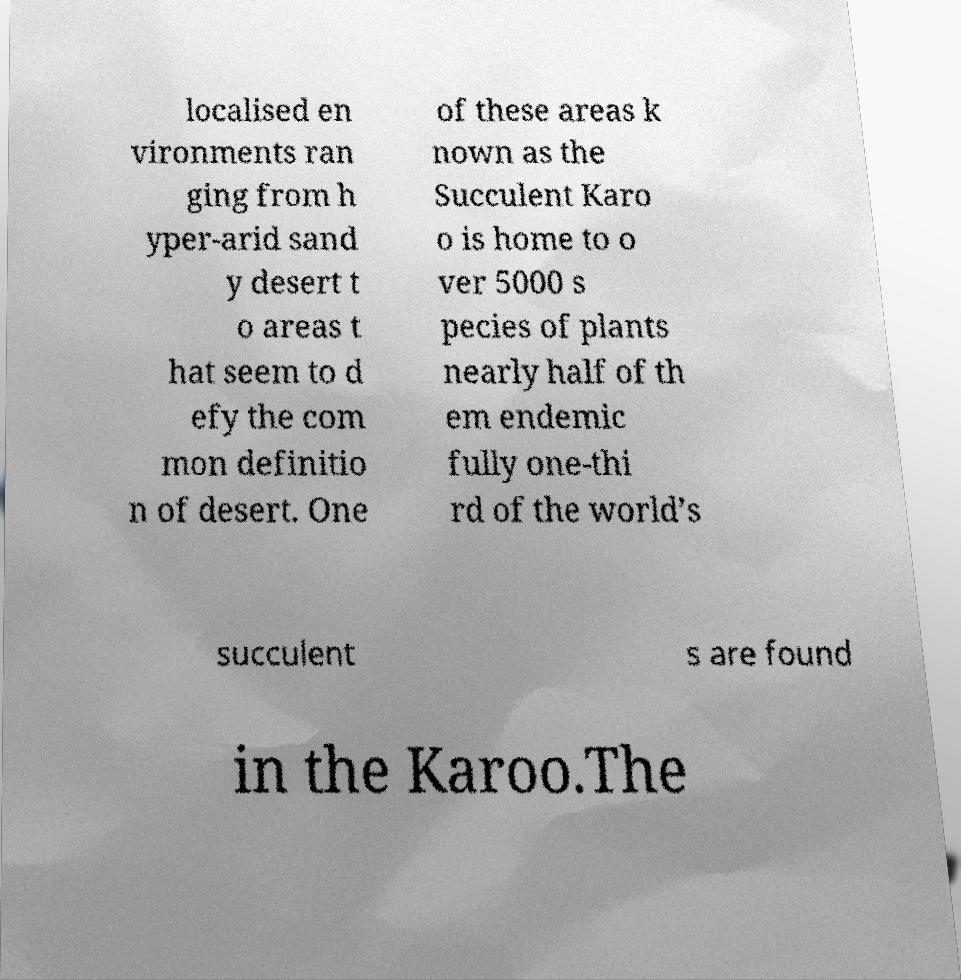Could you extract and type out the text from this image? localised en vironments ran ging from h yper-arid sand y desert t o areas t hat seem to d efy the com mon definitio n of desert. One of these areas k nown as the Succulent Karo o is home to o ver 5000 s pecies of plants nearly half of th em endemic fully one-thi rd of the world’s succulent s are found in the Karoo.The 